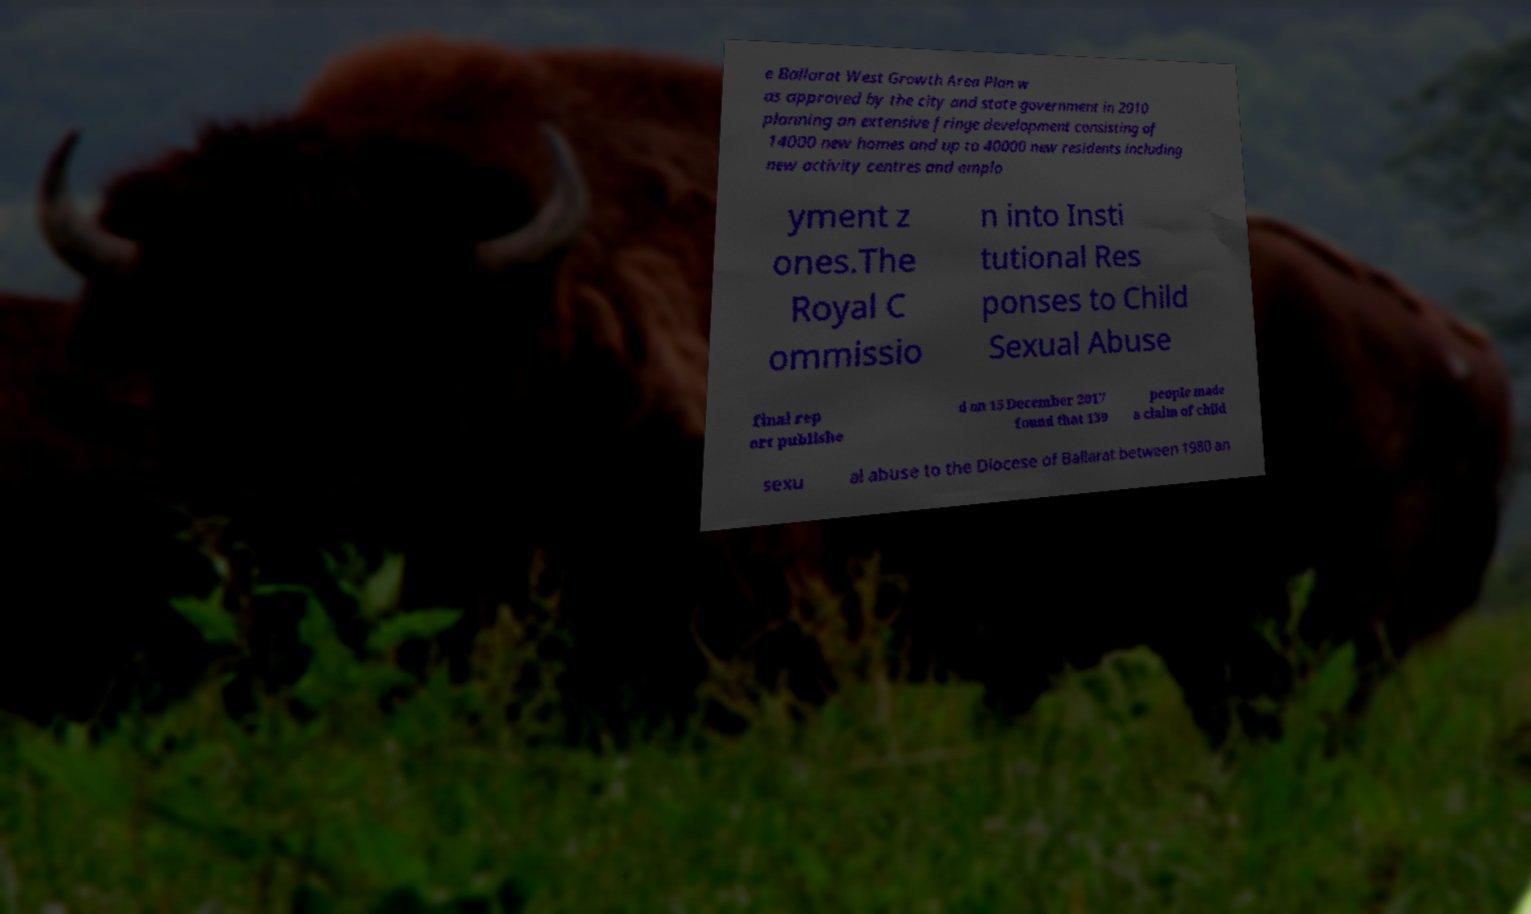Could you assist in decoding the text presented in this image and type it out clearly? e Ballarat West Growth Area Plan w as approved by the city and state government in 2010 planning an extensive fringe development consisting of 14000 new homes and up to 40000 new residents including new activity centres and emplo yment z ones.The Royal C ommissio n into Insti tutional Res ponses to Child Sexual Abuse final rep ort publishe d on 15 December 2017 found that 139 people made a claim of child sexu al abuse to the Diocese of Ballarat between 1980 an 